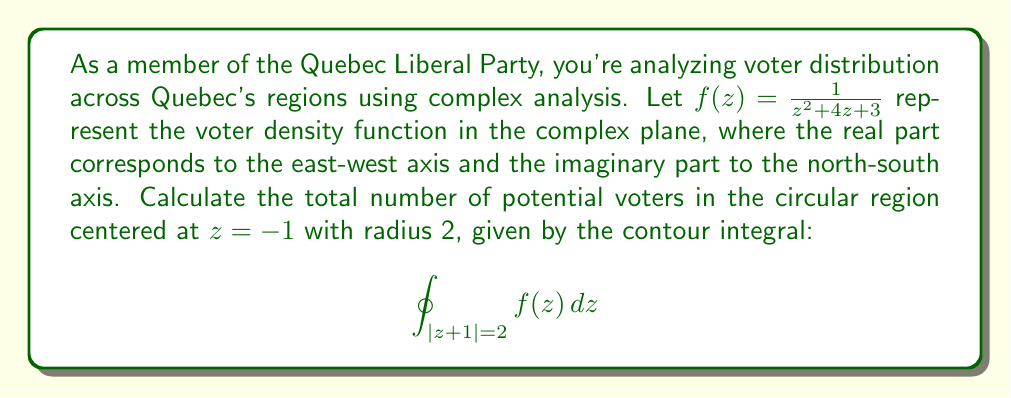Can you solve this math problem? To solve this problem, we'll use the Residue Theorem from complex analysis. The steps are as follows:

1) First, we need to find the poles of $f(z)$ inside the given contour. The denominator of $f(z)$ can be factored as:

   $z^2 + 4z + 3 = (z+1)(z+3)$

   So, the poles are at $z = -1$ and $z = -3$.

2) The contour is a circle with center at $z = -1$ and radius 2. This means that only the pole at $z = -1$ is inside our contour.

3) To find the residue at $z = -1$, we use the formula for a simple pole:

   $$\text{Res}(f, -1) = \lim_{z \to -1} (z+1)f(z) = \lim_{z \to -1} \frac{z+1}{(z+1)(z+3)} = \frac{1}{z+3}\bigg|_{z=-1} = \frac{1}{2}$$

4) Now we can apply the Residue Theorem:

   $$\oint_{|z+1|=2} f(z) \, dz = 2\pi i \sum \text{Residues inside the contour}$$

5) In this case, we only have one residue inside the contour:

   $$\oint_{|z+1|=2} f(z) \, dz = 2\pi i \cdot \frac{1}{2} = \pi i$$

This result represents the total number of potential voters in the given region, with the imaginary unit $i$ possibly indicating a phase shift or directional component in the voter distribution.
Answer: $\pi i$ 